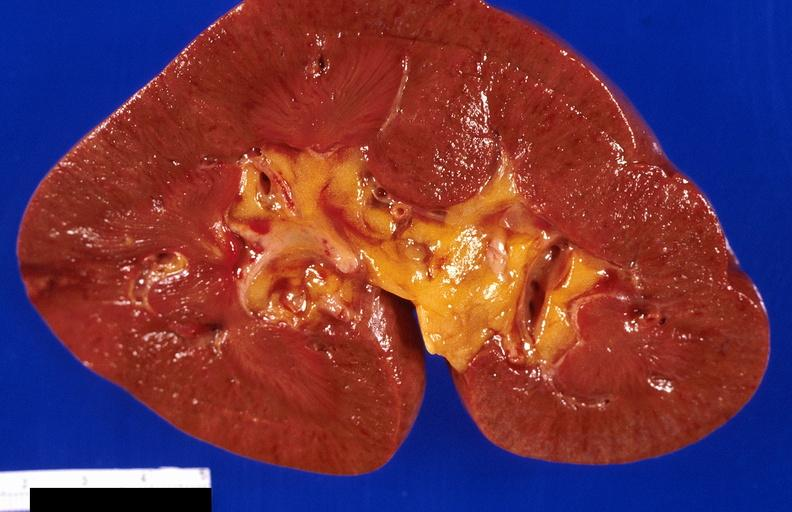what does this image show?
Answer the question using a single word or phrase. Kidney 